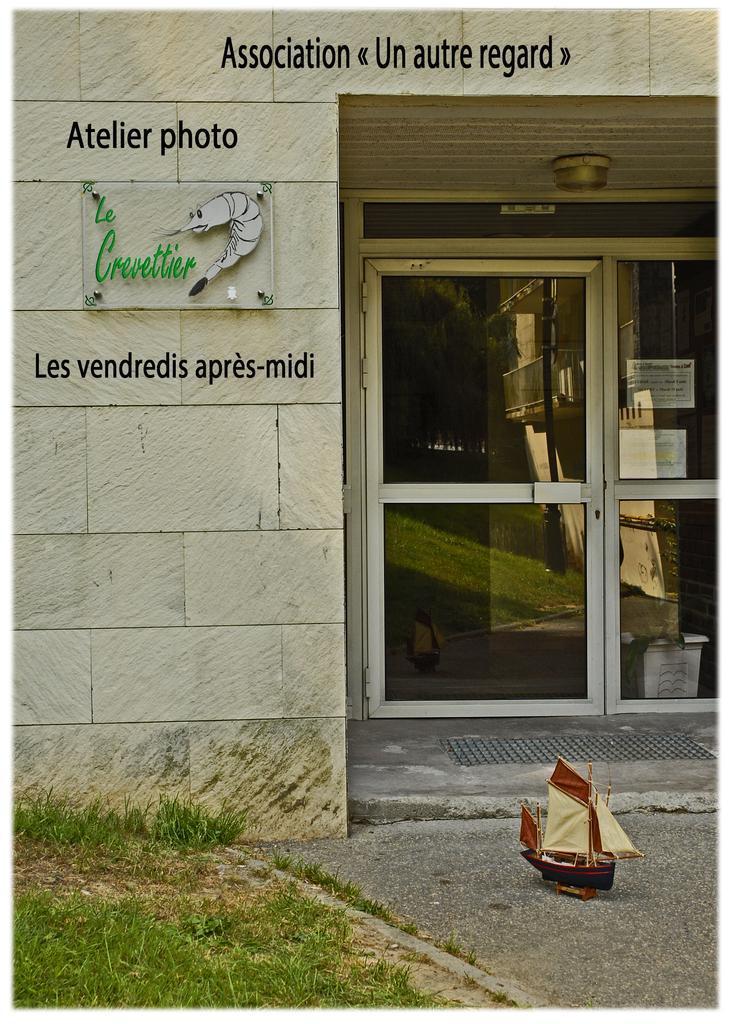In one or two sentences, can you explain what this image depicts? At the bottom of the picture, we see grass. In the right bottom of the picture, we see the road and a sailboat. On the left side, we see a white wall on which a glass board with some text written on it, is placed. On the right side, we see a glass door and a doormat. 